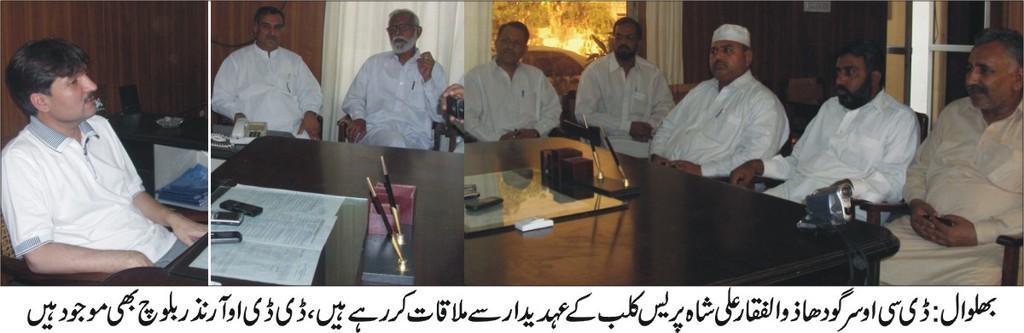Can you describe this image briefly? In this image there are three different images. On the left there is a man, he wears a t shirt, he is sitting. In the middle there is a table on that there are papers, mobiles, pens, in front of the table there are two men. On the right there are five men sitting, in front of them there is a table. In the background there are curtains, light, plants and door. At the bottom there is a text. 